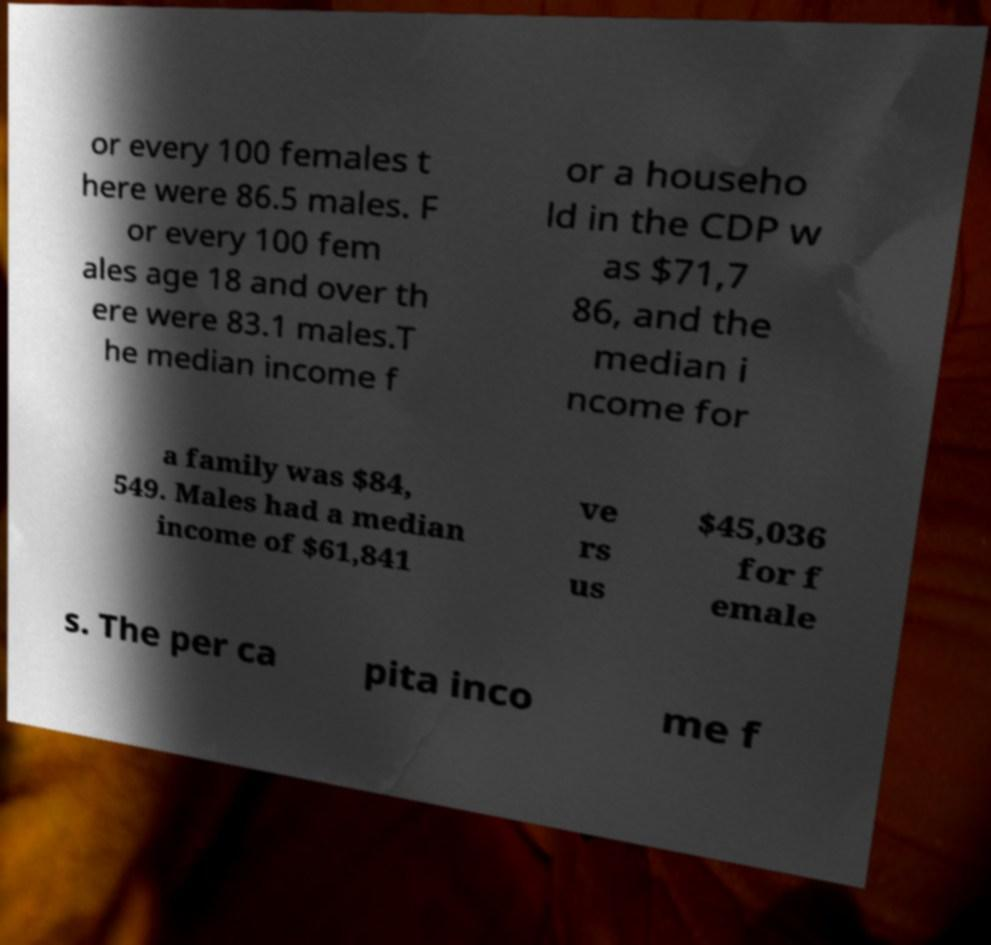Can you accurately transcribe the text from the provided image for me? or every 100 females t here were 86.5 males. F or every 100 fem ales age 18 and over th ere were 83.1 males.T he median income f or a househo ld in the CDP w as $71,7 86, and the median i ncome for a family was $84, 549. Males had a median income of $61,841 ve rs us $45,036 for f emale s. The per ca pita inco me f 